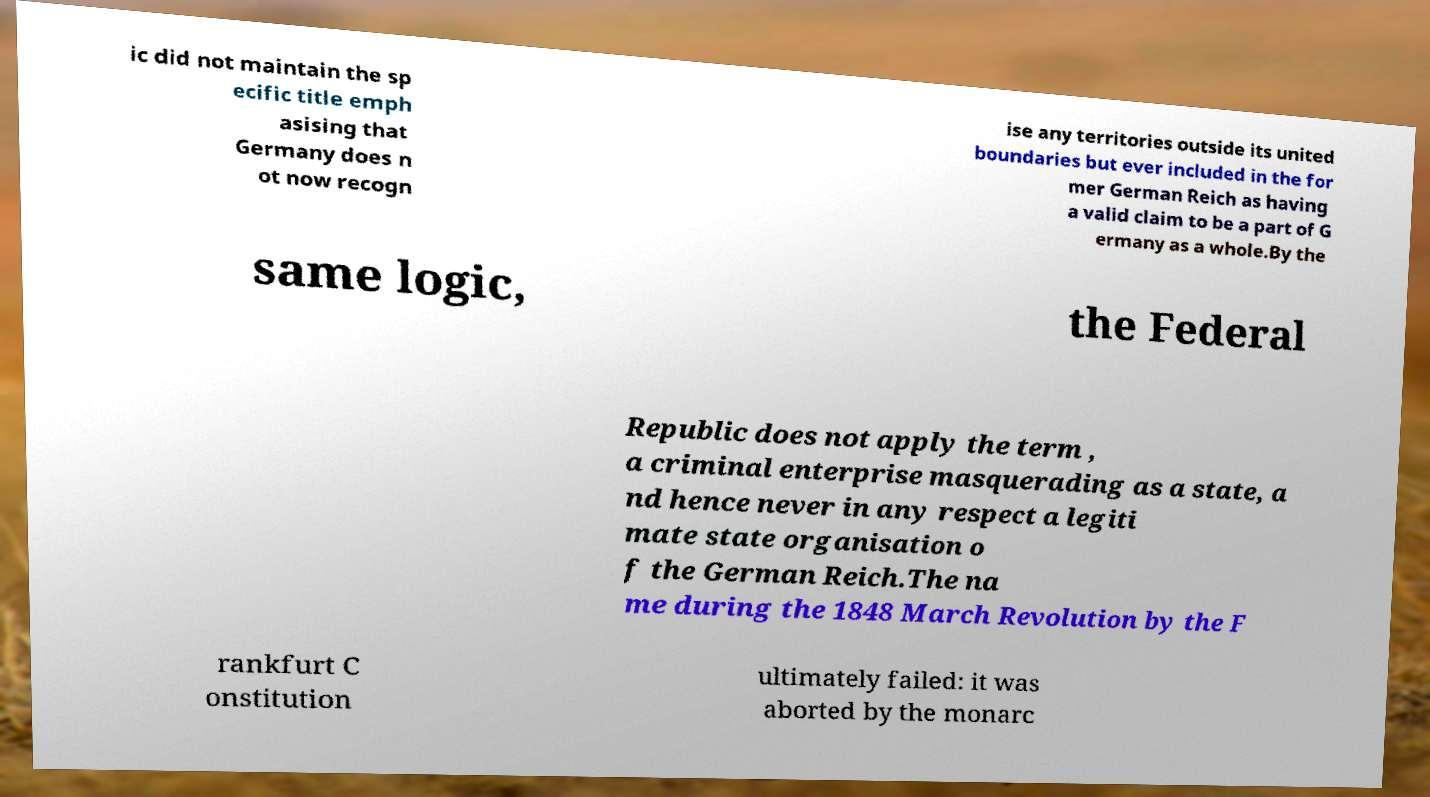Please read and relay the text visible in this image. What does it say? ic did not maintain the sp ecific title emph asising that Germany does n ot now recogn ise any territories outside its united boundaries but ever included in the for mer German Reich as having a valid claim to be a part of G ermany as a whole.By the same logic, the Federal Republic does not apply the term , a criminal enterprise masquerading as a state, a nd hence never in any respect a legiti mate state organisation o f the German Reich.The na me during the 1848 March Revolution by the F rankfurt C onstitution ultimately failed: it was aborted by the monarc 